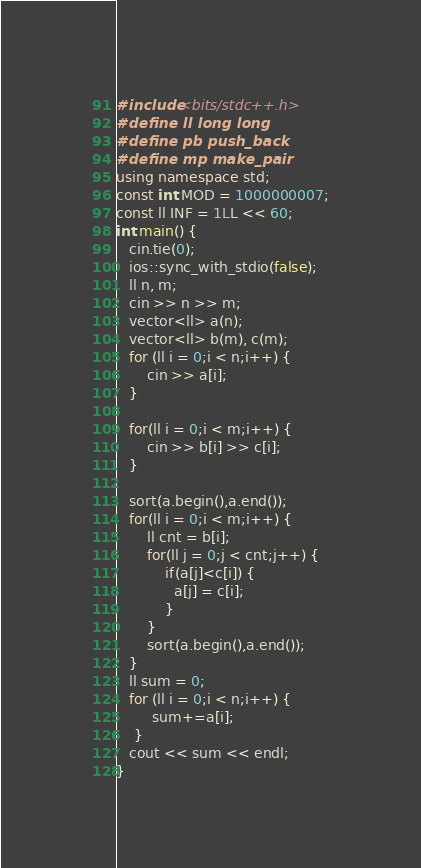<code> <loc_0><loc_0><loc_500><loc_500><_C++_>#include<bits/stdc++.h>
#define ll long long
#define pb push_back
#define mp make_pair
using namespace std;
const int MOD = 1000000007;
const ll INF = 1LL << 60;
int main() {
   cin.tie(0);
   ios::sync_with_stdio(false);
   ll n, m;
   cin >> n >> m;
   vector<ll> a(n);
   vector<ll> b(m), c(m);
   for (ll i = 0;i < n;i++) {
       cin >> a[i];
   }

   for(ll i = 0;i < m;i++) {
       cin >> b[i] >> c[i];
   }

   sort(a.begin(),a.end());
   for(ll i = 0;i < m;i++) {
       ll cnt = b[i];
       for(ll j = 0;j < cnt;j++) {
           if(a[j]<c[i]) {
             a[j] = c[i];
           }
       }
       sort(a.begin(),a.end());
   }
   ll sum = 0;
   for (ll i = 0;i < n;i++) {
        sum+=a[i];
    }
   cout << sum << endl;
}</code> 